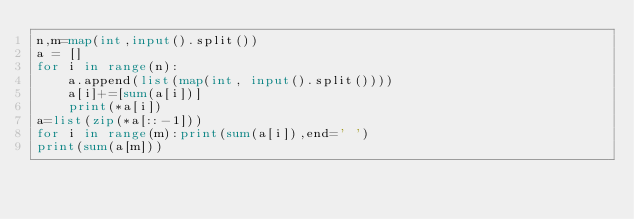<code> <loc_0><loc_0><loc_500><loc_500><_Python_>n,m=map(int,input().split())
a = []
for i in range(n):
    a.append(list(map(int, input().split())))
    a[i]+=[sum(a[i])]
    print(*a[i])
a=list(zip(*a[::-1]))
for i in range(m):print(sum(a[i]),end=' ')
print(sum(a[m]))</code> 